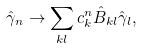Convert formula to latex. <formula><loc_0><loc_0><loc_500><loc_500>\hat { \gamma } _ { n } \rightarrow \sum _ { k l } c ^ { n } _ { k } \hat { B } _ { k l } \hat { \gamma } _ { l } ,</formula> 